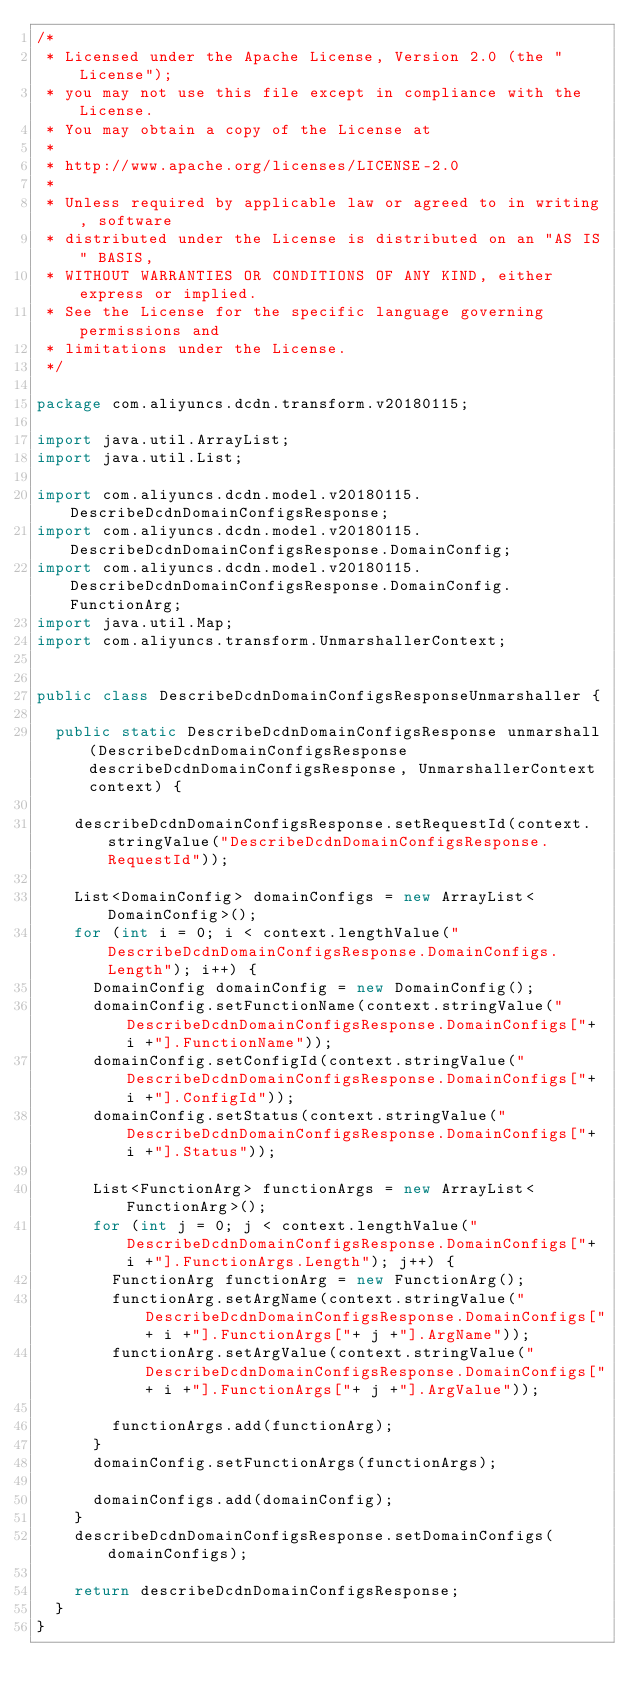<code> <loc_0><loc_0><loc_500><loc_500><_Java_>/*
 * Licensed under the Apache License, Version 2.0 (the "License");
 * you may not use this file except in compliance with the License.
 * You may obtain a copy of the License at
 *
 * http://www.apache.org/licenses/LICENSE-2.0
 *
 * Unless required by applicable law or agreed to in writing, software
 * distributed under the License is distributed on an "AS IS" BASIS,
 * WITHOUT WARRANTIES OR CONDITIONS OF ANY KIND, either express or implied.
 * See the License for the specific language governing permissions and
 * limitations under the License.
 */

package com.aliyuncs.dcdn.transform.v20180115;

import java.util.ArrayList;
import java.util.List;

import com.aliyuncs.dcdn.model.v20180115.DescribeDcdnDomainConfigsResponse;
import com.aliyuncs.dcdn.model.v20180115.DescribeDcdnDomainConfigsResponse.DomainConfig;
import com.aliyuncs.dcdn.model.v20180115.DescribeDcdnDomainConfigsResponse.DomainConfig.FunctionArg;
import java.util.Map;
import com.aliyuncs.transform.UnmarshallerContext;


public class DescribeDcdnDomainConfigsResponseUnmarshaller {

	public static DescribeDcdnDomainConfigsResponse unmarshall(DescribeDcdnDomainConfigsResponse describeDcdnDomainConfigsResponse, UnmarshallerContext context) {
		
		describeDcdnDomainConfigsResponse.setRequestId(context.stringValue("DescribeDcdnDomainConfigsResponse.RequestId"));

		List<DomainConfig> domainConfigs = new ArrayList<DomainConfig>();
		for (int i = 0; i < context.lengthValue("DescribeDcdnDomainConfigsResponse.DomainConfigs.Length"); i++) {
			DomainConfig domainConfig = new DomainConfig();
			domainConfig.setFunctionName(context.stringValue("DescribeDcdnDomainConfigsResponse.DomainConfigs["+ i +"].FunctionName"));
			domainConfig.setConfigId(context.stringValue("DescribeDcdnDomainConfigsResponse.DomainConfigs["+ i +"].ConfigId"));
			domainConfig.setStatus(context.stringValue("DescribeDcdnDomainConfigsResponse.DomainConfigs["+ i +"].Status"));

			List<FunctionArg> functionArgs = new ArrayList<FunctionArg>();
			for (int j = 0; j < context.lengthValue("DescribeDcdnDomainConfigsResponse.DomainConfigs["+ i +"].FunctionArgs.Length"); j++) {
				FunctionArg functionArg = new FunctionArg();
				functionArg.setArgName(context.stringValue("DescribeDcdnDomainConfigsResponse.DomainConfigs["+ i +"].FunctionArgs["+ j +"].ArgName"));
				functionArg.setArgValue(context.stringValue("DescribeDcdnDomainConfigsResponse.DomainConfigs["+ i +"].FunctionArgs["+ j +"].ArgValue"));

				functionArgs.add(functionArg);
			}
			domainConfig.setFunctionArgs(functionArgs);

			domainConfigs.add(domainConfig);
		}
		describeDcdnDomainConfigsResponse.setDomainConfigs(domainConfigs);
	 
	 	return describeDcdnDomainConfigsResponse;
	}
}</code> 